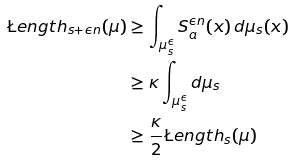<formula> <loc_0><loc_0><loc_500><loc_500>\L e n g t h _ { s + \epsilon n } ( \mu ) & \geq \int _ { \mu _ { s } ^ { \epsilon } } S ^ { \epsilon n } _ { a } ( x ) \, d \mu _ { s } ( x ) \\ & \geq \kappa \int _ { \mu _ { s } ^ { \epsilon } } d \mu _ { s } \\ & \geq \frac { \kappa } { 2 } \L e n g t h _ { s } ( \mu )</formula> 